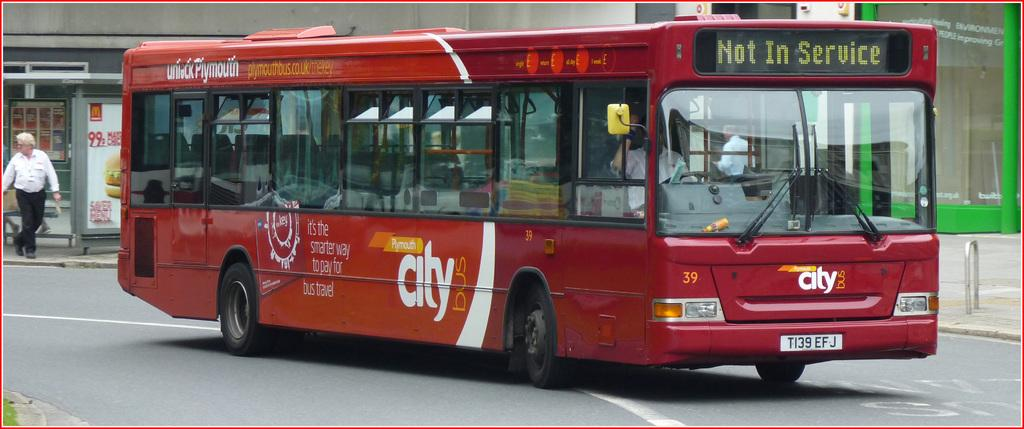What type of vehicle is on the road in the image? There is a bus on the road in the image. What are the people in the image doing? There are people walking on the pavement in the image. What type of structure can be seen in the image? There are metal rods visible in the image. Where do people wait for the bus in the image? There is a bus stop in the image. What can be used to display information in the image? Display boards are present in the image. What type of structures can be seen in the background of the image? There are buildings in the image. What type of jam is being served at the bus stop in the image? There is no jam present in the image; it features a bus on the road, people walking, metal rods, a bus stop, display boards, and buildings. What type of wine is being advertised on the display boards in the image? There is no wine advertised on the display boards in the image; they are used to display information about bus routes or schedules. 